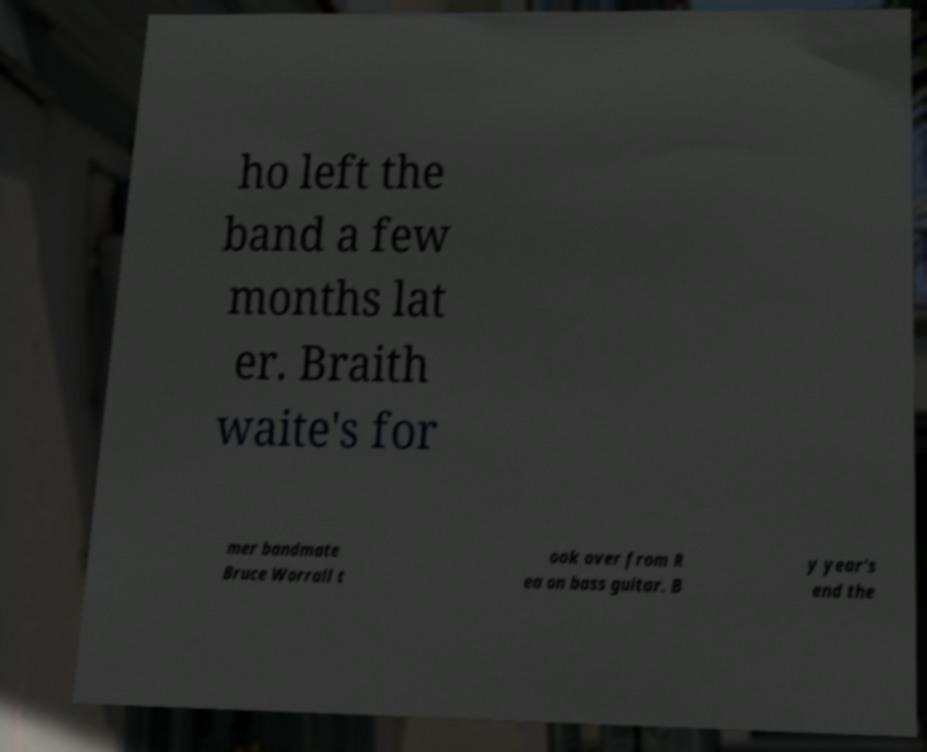Could you assist in decoding the text presented in this image and type it out clearly? ho left the band a few months lat er. Braith waite's for mer bandmate Bruce Worrall t ook over from R ea on bass guitar. B y year's end the 